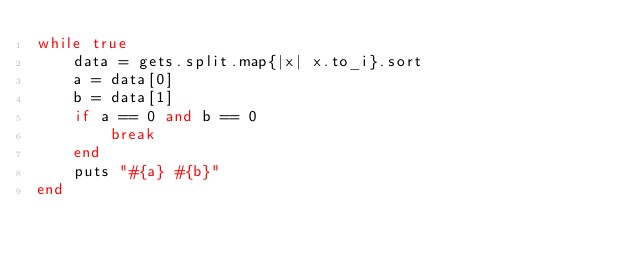Convert code to text. <code><loc_0><loc_0><loc_500><loc_500><_Ruby_>while true
	data = gets.split.map{|x| x.to_i}.sort
	a = data[0]
	b = data[1]
	if a == 0 and b == 0
		break
	end
	puts "#{a} #{b}"
end</code> 